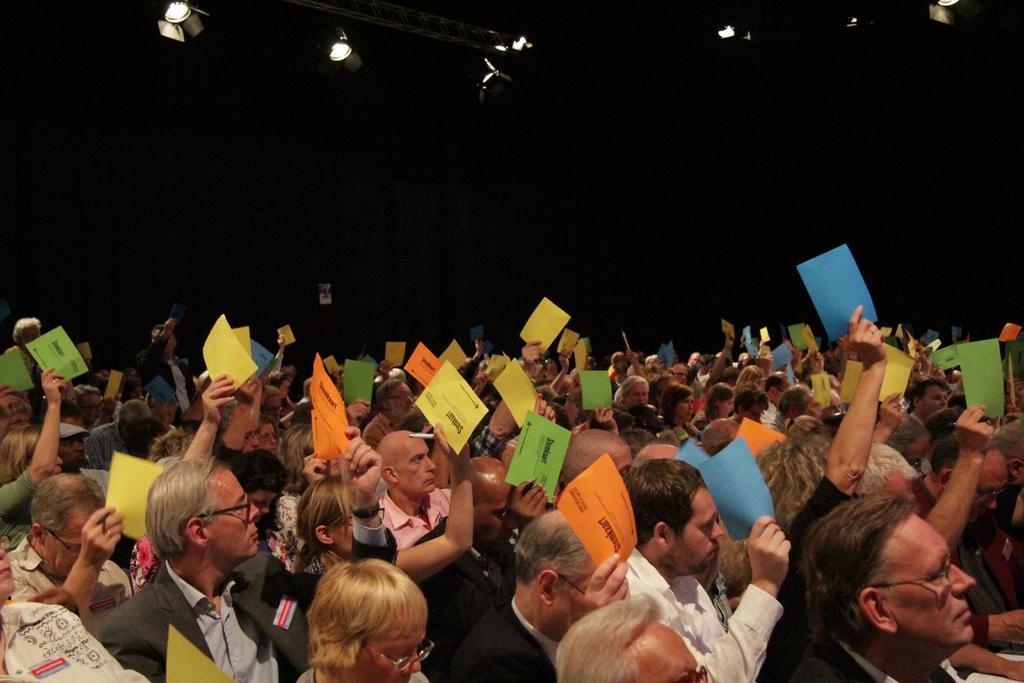How would you summarize this image in a sentence or two? In this picture I can see few people are sitting and holding papers in their hands and I can see few lights on the ceiling and I can see dark background. 